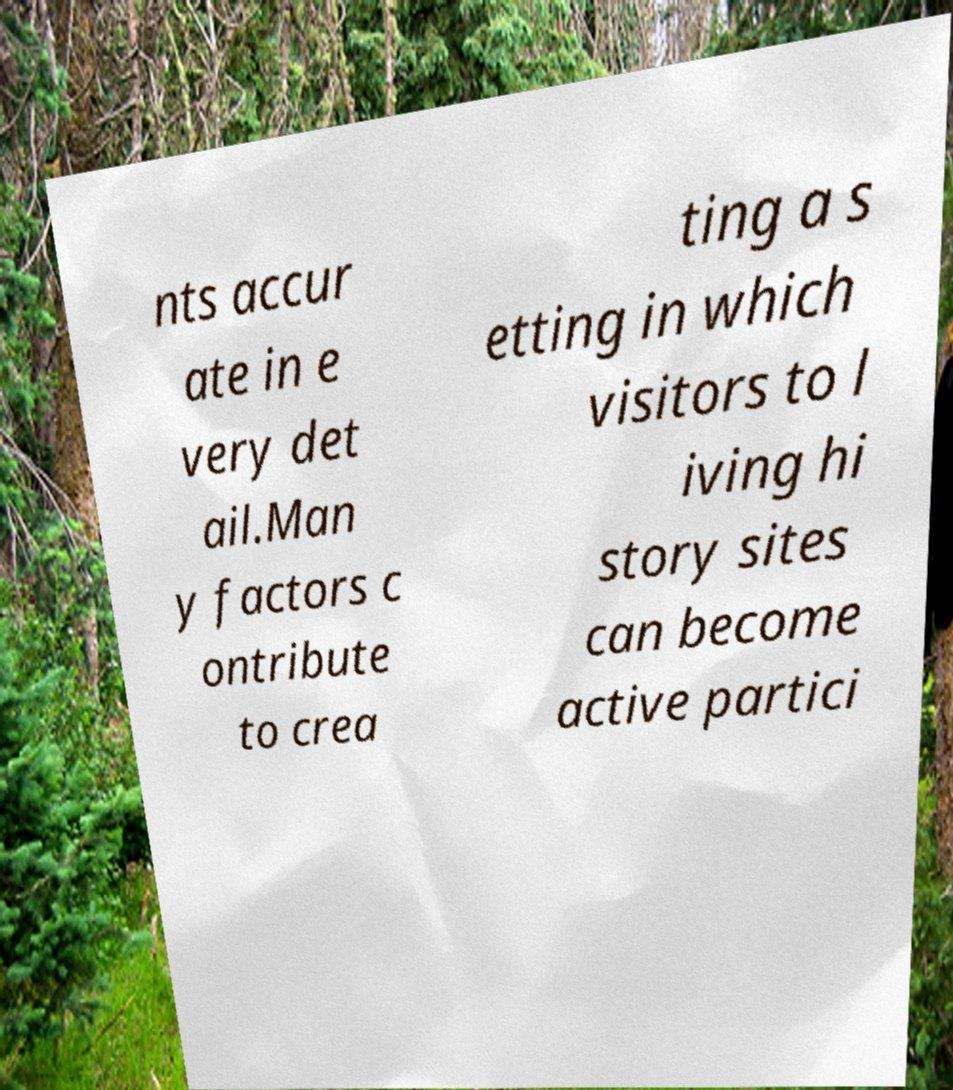Please read and relay the text visible in this image. What does it say? nts accur ate in e very det ail.Man y factors c ontribute to crea ting a s etting in which visitors to l iving hi story sites can become active partici 